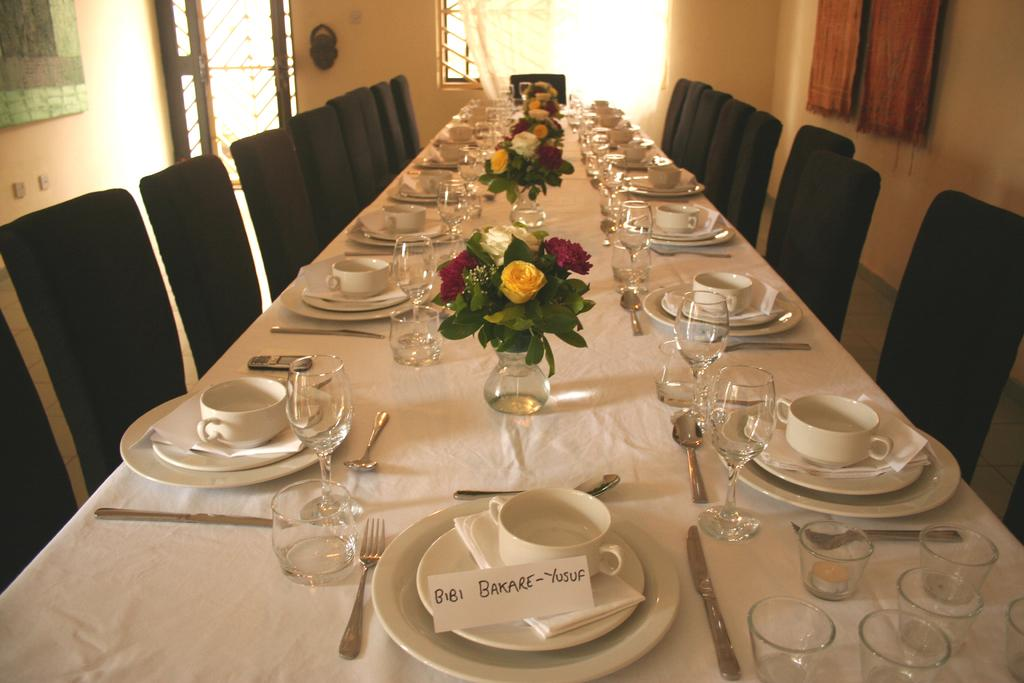What type of furniture is in the image? There is a dining table in the image. Are there any seats near the dining table? Yes, there are chairs near the dining table. What can be found on the dining table? There are many things on the table. What type of game is being played on the dining table in the image? There is no game being played on the dining table in the image. 